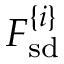Convert formula to latex. <formula><loc_0><loc_0><loc_500><loc_500>F _ { s d } ^ { \{ i \} }</formula> 